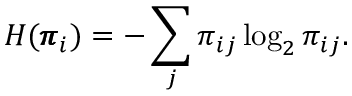<formula> <loc_0><loc_0><loc_500><loc_500>H ( \pm b { \pi } _ { i } ) = - \sum _ { j } \pi _ { i j } \log _ { 2 } \pi _ { i j } .</formula> 